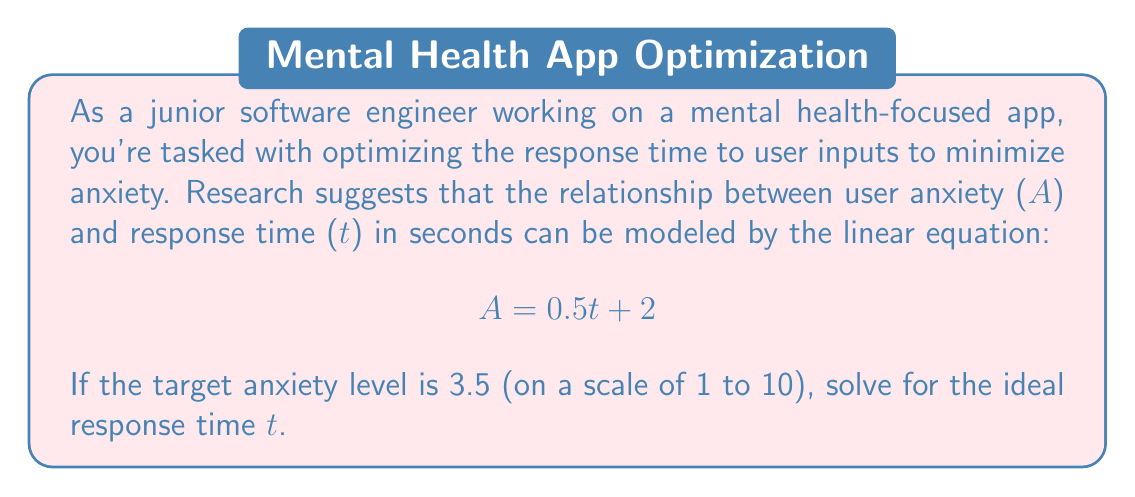Provide a solution to this math problem. To solve this problem, we'll use the given linear equation and follow these steps:

1. Start with the given equation:
   $$ A = 0.5t + 2 $$

2. Substitute the target anxiety level A = 3.5:
   $$ 3.5 = 0.5t + 2 $$

3. Subtract 2 from both sides to isolate the term with t:
   $$ 3.5 - 2 = 0.5t + 2 - 2 $$
   $$ 1.5 = 0.5t $$

4. Divide both sides by 0.5 to solve for t:
   $$ \frac{1.5}{0.5} = \frac{0.5t}{0.5} $$
   $$ 3 = t $$

Therefore, the ideal response time to achieve an anxiety level of 3.5 is 3 seconds.
Answer: $t = 3$ seconds 